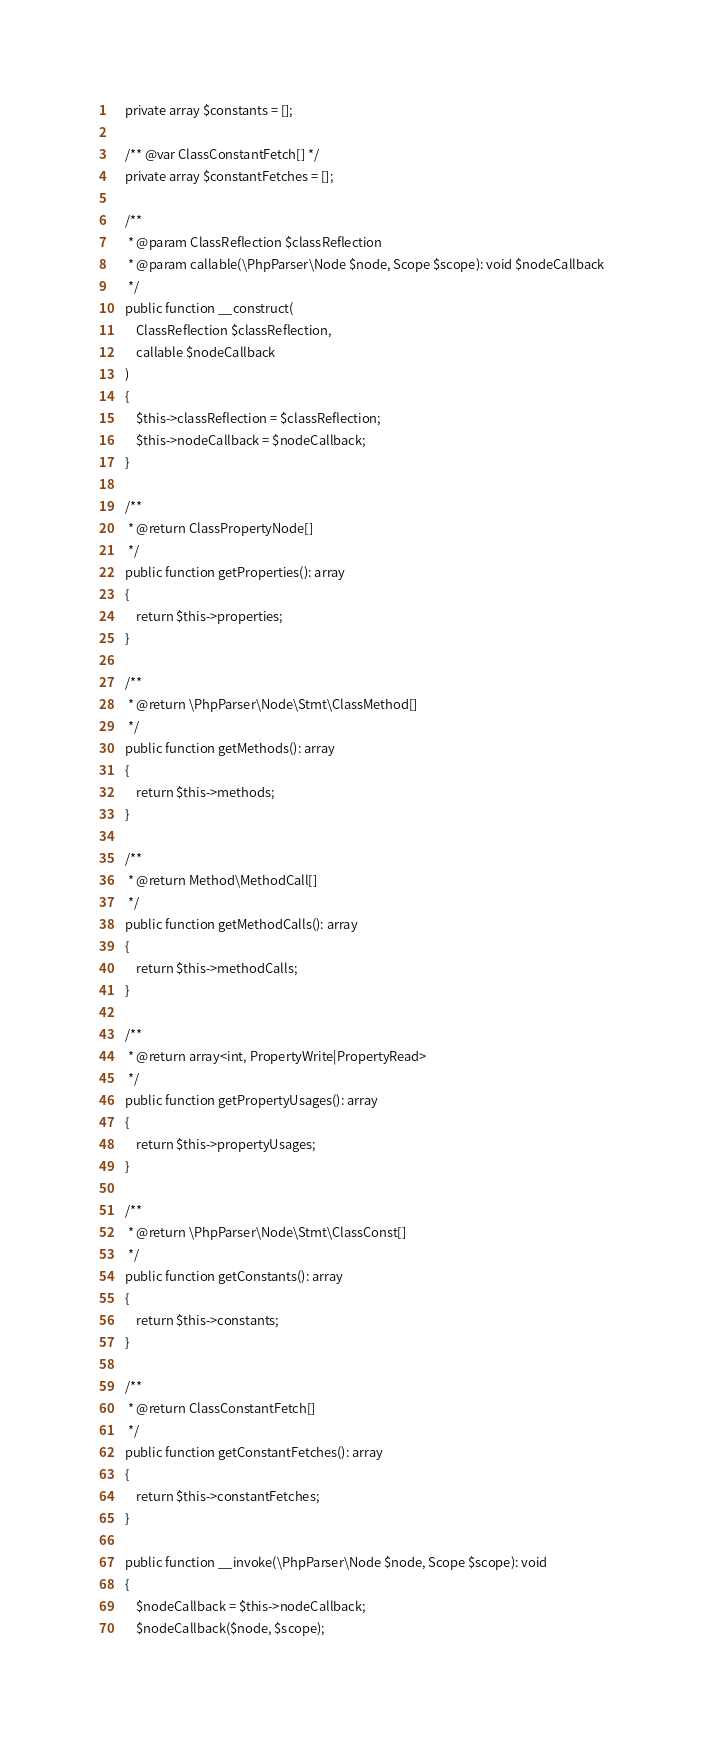Convert code to text. <code><loc_0><loc_0><loc_500><loc_500><_PHP_>	private array $constants = [];

	/** @var ClassConstantFetch[] */
	private array $constantFetches = [];

	/**
	 * @param ClassReflection $classReflection
	 * @param callable(\PhpParser\Node $node, Scope $scope): void $nodeCallback
	 */
	public function __construct(
		ClassReflection $classReflection,
		callable $nodeCallback
	)
	{
		$this->classReflection = $classReflection;
		$this->nodeCallback = $nodeCallback;
	}

	/**
	 * @return ClassPropertyNode[]
	 */
	public function getProperties(): array
	{
		return $this->properties;
	}

	/**
	 * @return \PhpParser\Node\Stmt\ClassMethod[]
	 */
	public function getMethods(): array
	{
		return $this->methods;
	}

	/**
	 * @return Method\MethodCall[]
	 */
	public function getMethodCalls(): array
	{
		return $this->methodCalls;
	}

	/**
	 * @return array<int, PropertyWrite|PropertyRead>
	 */
	public function getPropertyUsages(): array
	{
		return $this->propertyUsages;
	}

	/**
	 * @return \PhpParser\Node\Stmt\ClassConst[]
	 */
	public function getConstants(): array
	{
		return $this->constants;
	}

	/**
	 * @return ClassConstantFetch[]
	 */
	public function getConstantFetches(): array
	{
		return $this->constantFetches;
	}

	public function __invoke(\PhpParser\Node $node, Scope $scope): void
	{
		$nodeCallback = $this->nodeCallback;
		$nodeCallback($node, $scope);</code> 